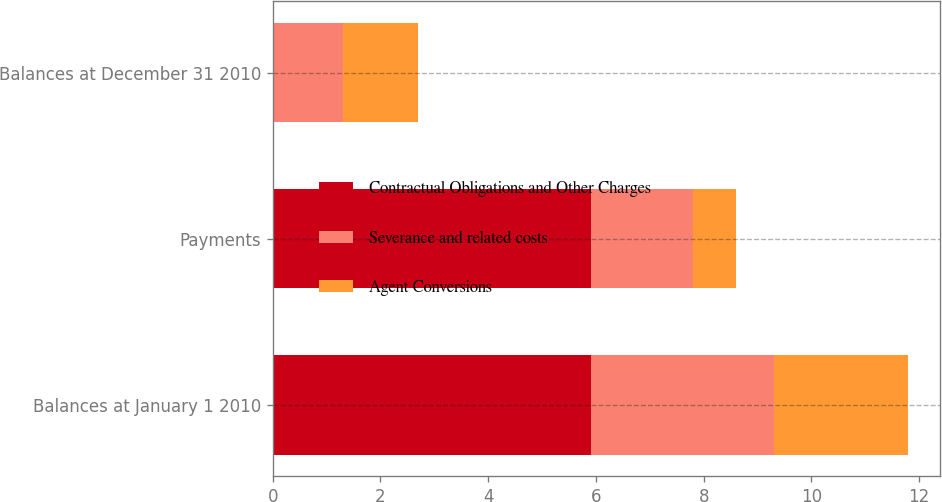Convert chart. <chart><loc_0><loc_0><loc_500><loc_500><stacked_bar_chart><ecel><fcel>Balances at January 1 2010<fcel>Payments<fcel>Balances at December 31 2010<nl><fcel>Contractual Obligations and Other Charges<fcel>5.9<fcel>5.9<fcel>0<nl><fcel>Severance and related costs<fcel>3.4<fcel>1.9<fcel>1.3<nl><fcel>Agent Conversions<fcel>2.5<fcel>0.8<fcel>1.4<nl></chart> 